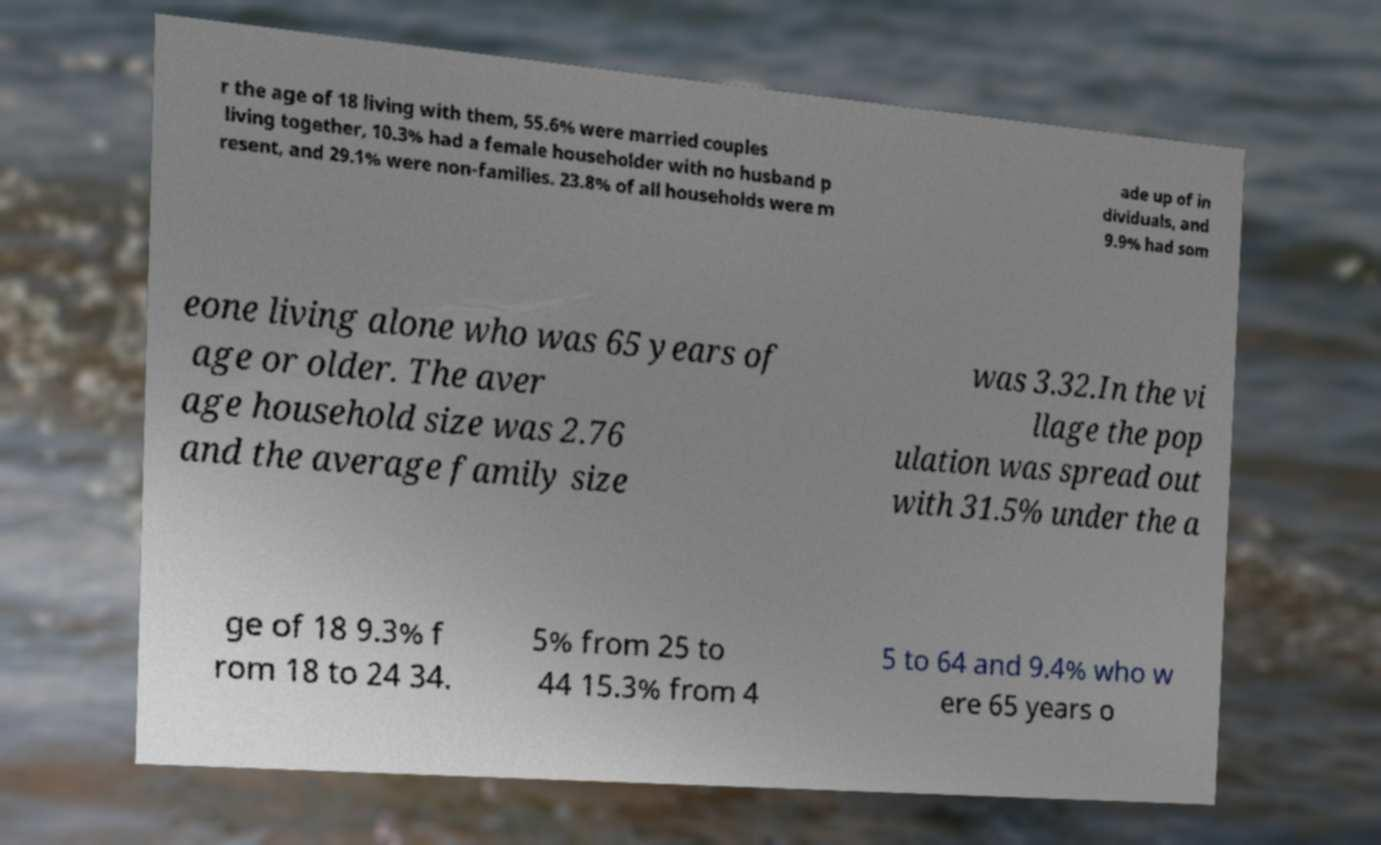There's text embedded in this image that I need extracted. Can you transcribe it verbatim? r the age of 18 living with them, 55.6% were married couples living together, 10.3% had a female householder with no husband p resent, and 29.1% were non-families. 23.8% of all households were m ade up of in dividuals, and 9.9% had som eone living alone who was 65 years of age or older. The aver age household size was 2.76 and the average family size was 3.32.In the vi llage the pop ulation was spread out with 31.5% under the a ge of 18 9.3% f rom 18 to 24 34. 5% from 25 to 44 15.3% from 4 5 to 64 and 9.4% who w ere 65 years o 